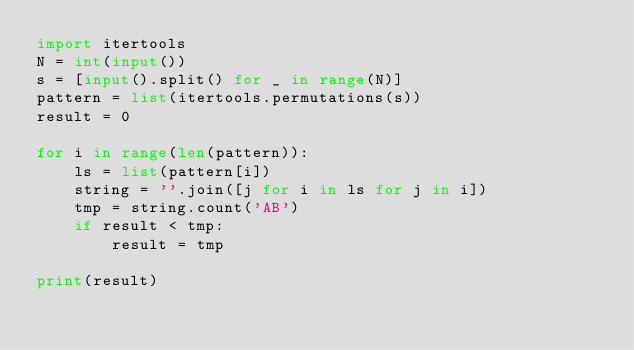Convert code to text. <code><loc_0><loc_0><loc_500><loc_500><_Python_>import itertools
N = int(input())
s = [input().split() for _ in range(N)]
pattern = list(itertools.permutations(s))
result = 0

for i in range(len(pattern)):
    ls = list(pattern[i])
    string = ''.join([j for i in ls for j in i])
    tmp = string.count('AB')
    if result < tmp:
        result = tmp

print(result)</code> 